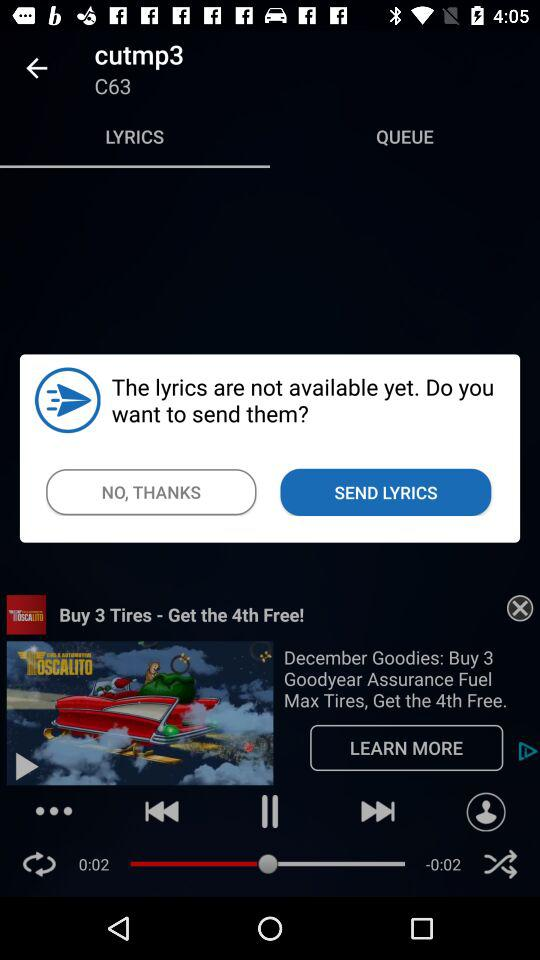Which tab is selected? The selected tab is "LYRICS". 